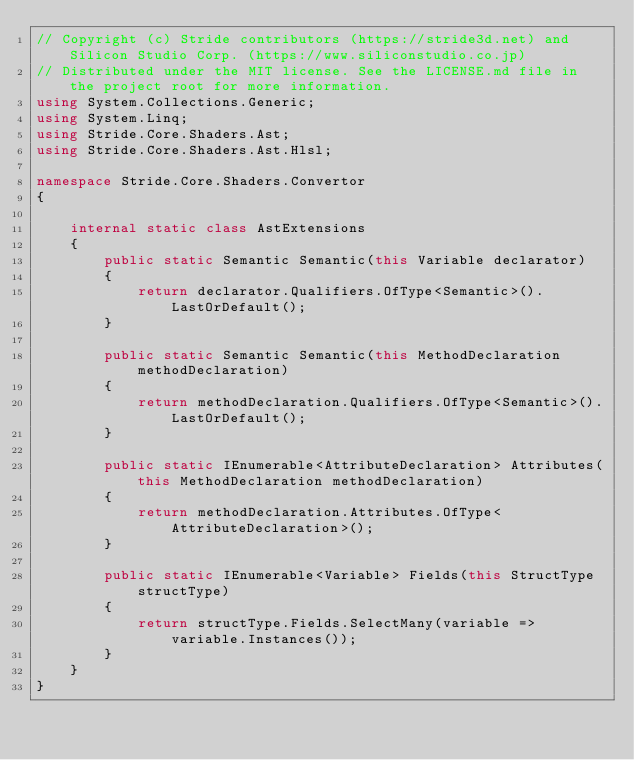Convert code to text. <code><loc_0><loc_0><loc_500><loc_500><_C#_>// Copyright (c) Stride contributors (https://stride3d.net) and Silicon Studio Corp. (https://www.siliconstudio.co.jp)
// Distributed under the MIT license. See the LICENSE.md file in the project root for more information.
using System.Collections.Generic;
using System.Linq;
using Stride.Core.Shaders.Ast;
using Stride.Core.Shaders.Ast.Hlsl;

namespace Stride.Core.Shaders.Convertor
{

    internal static class AstExtensions
    {
        public static Semantic Semantic(this Variable declarator)
        {
            return declarator.Qualifiers.OfType<Semantic>().LastOrDefault();
        }

        public static Semantic Semantic(this MethodDeclaration methodDeclaration)
        {
            return methodDeclaration.Qualifiers.OfType<Semantic>().LastOrDefault();
        }

        public static IEnumerable<AttributeDeclaration> Attributes(this MethodDeclaration methodDeclaration)
        {
            return methodDeclaration.Attributes.OfType<AttributeDeclaration>();
        }

        public static IEnumerable<Variable> Fields(this StructType structType)
        {
            return structType.Fields.SelectMany(variable => variable.Instances());
        }
    }
}
</code> 